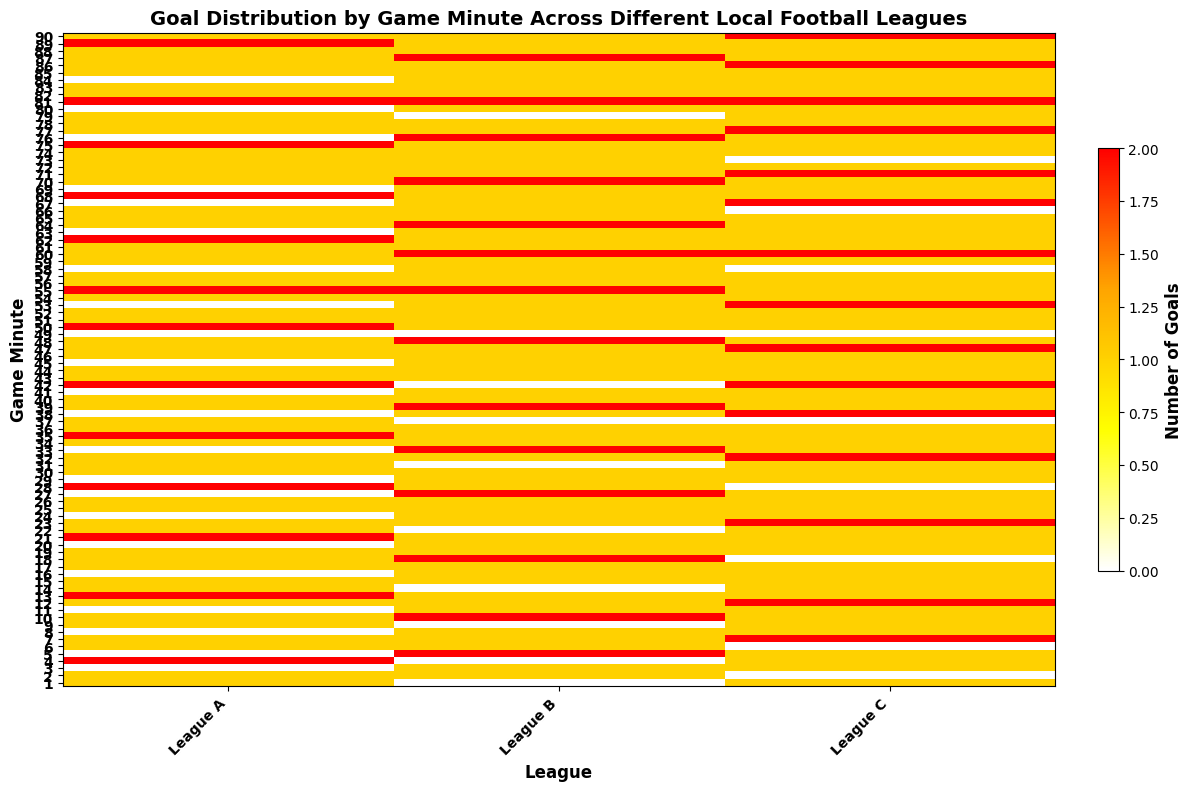Which league scored the most goals in the 10th minute? Look at the 10th minute row and compare the number of goals across all leagues. League B has the most, with 2 goals in the 10th minute.
Answer: League B At which minute did League A score the highest number of goals? Inspect each minute for League A and find the minute where the number of goals is highest. League A scored the highest number of goals (2) at minutes 4, 13, 21, 28, 35, 42, 50, 55, 62, 68, 75, 81, and 89.
Answer: 4, 13, 21, 28, 35, 42, 50, 55, 62, 68, 75, 81, 89 Which league has the most consistent goal-scoring pattern? Visually examine the color trends for each league from minute 1 to 90 and look for consistency in number of goals. League C appears to have the most consistent patterns with fewer empty (white) patches, implying regular goal scoring.
Answer: League C How many times did League B score 2 goals in a single minute? Count the yellow to red shaded cells in League B's column that represent 2 goals. League B has 17 instances where 2 goals were scored in a minute.
Answer: 17 What is the average number of goals per minute in League C? Sum all the goals in League C across all minutes and divide by 90 (the total number of minutes). There are 90 minutes, and summing the goals in League C gives a total of 108 goals. The average is 108/90 = 1.2.
Answer: 1.2 Which league scored more goals in the first 45 minutes (first half)? Sum the number of goals for each league from the 1st to the 45th minute. League A: 32, League B: 34, League C: 33. League B scored the most goals in the first 45 minutes.
Answer: League B Does League A score more goals early (1st half) or late (2nd half) in the game? Compare the sum of goals in the first 45 minutes to the sum in the last 45 minutes for League A. In the first 45 minutes, League A scores 32 goals, and in the last 45 minutes, it scores 34 goals. League A scores slightly more goals late in the game.
Answer: Late (2nd half) Which league shows the largest increase in goals during any time window of 10 minutes? Look for a rapid color change to warmer colors (yellow to red) over any 10-minute window for each league. League C shows significant increases during several 10-minute periods, such as from minute 62 to 72.
Answer: League C Which minute sees an overall peak in goal activity for all leagues combined? Identify the minute that has the most combined goals across all leagues. The 90th minute shows high goal activity across all leagues (multiple reds indicating 2 goals).
Answer: 90th minute Between minute 15 and 30, which league has the highest average number of goals per minute? Calculate the average number of goals per minute between the 15th and the 30th minute for each league. Summing the goals in that range: League A: 11 goals, League B: 13 goals, League C: 11 goals. Average: League A = 0.73, League B = 0.87, League C = 0.73. League B has the highest average.
Answer: League B 